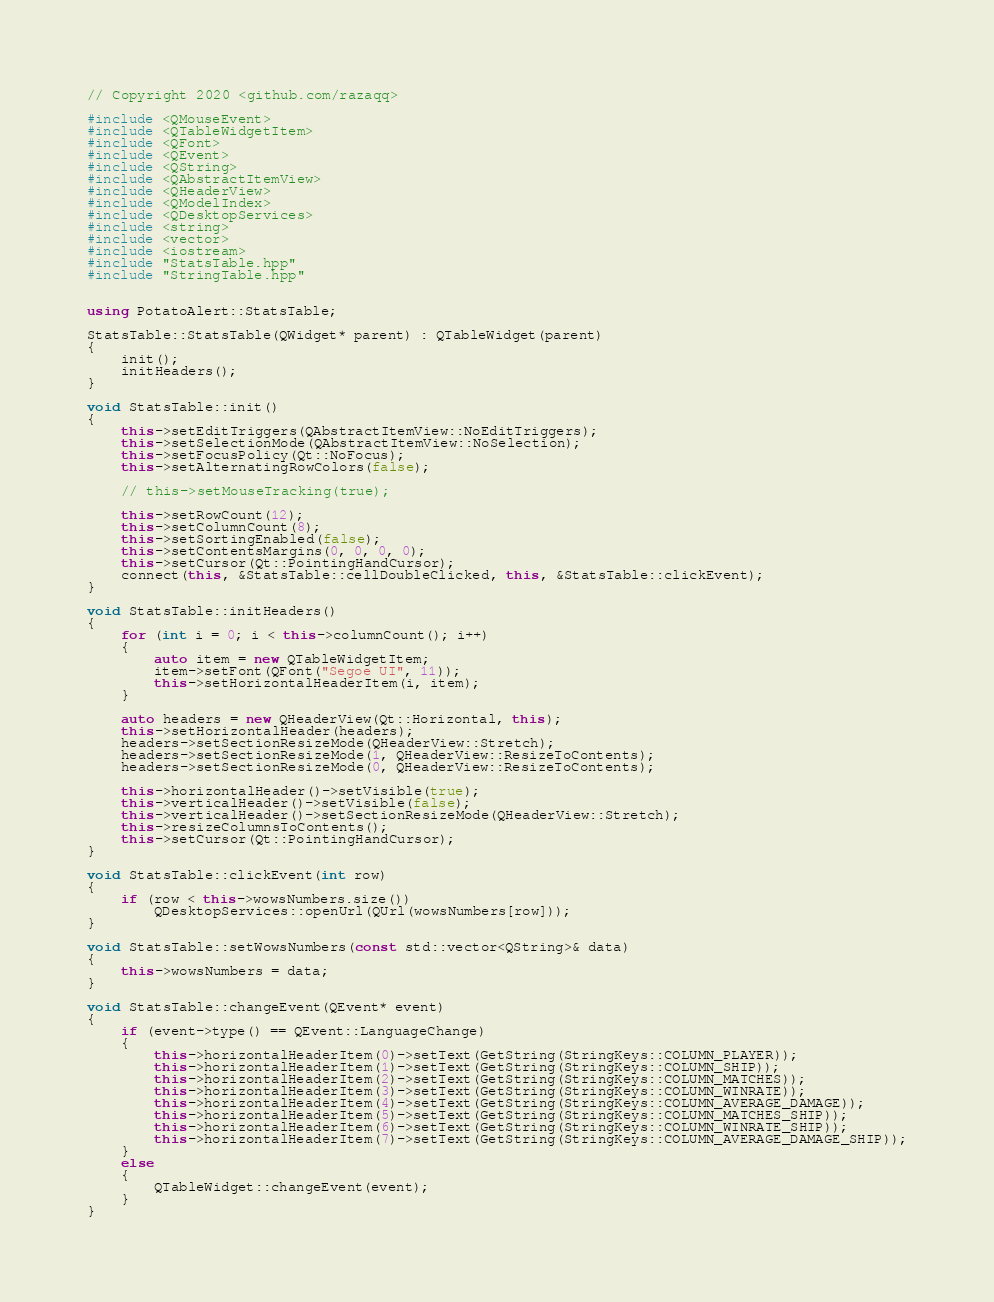<code> <loc_0><loc_0><loc_500><loc_500><_C++_>// Copyright 2020 <github.com/razaqq>

#include <QMouseEvent>
#include <QTableWidgetItem>
#include <QFont>
#include <QEvent>
#include <QString>
#include <QAbstractItemView>
#include <QHeaderView>
#include <QModelIndex>
#include <QDesktopServices>
#include <string>
#include <vector>
#include <iostream>
#include "StatsTable.hpp"
#include "StringTable.hpp"


using PotatoAlert::StatsTable;

StatsTable::StatsTable(QWidget* parent) : QTableWidget(parent)
{
	init();
	initHeaders();
}

void StatsTable::init()
{
	this->setEditTriggers(QAbstractItemView::NoEditTriggers);
	this->setSelectionMode(QAbstractItemView::NoSelection);
	this->setFocusPolicy(Qt::NoFocus);
	this->setAlternatingRowColors(false);

	// this->setMouseTracking(true);

	this->setRowCount(12);
	this->setColumnCount(8);
	this->setSortingEnabled(false);
	this->setContentsMargins(0, 0, 0, 0);
	this->setCursor(Qt::PointingHandCursor);
	connect(this, &StatsTable::cellDoubleClicked, this, &StatsTable::clickEvent);
}

void StatsTable::initHeaders()
{
	for (int i = 0; i < this->columnCount(); i++)
	{
		auto item = new QTableWidgetItem;
		item->setFont(QFont("Segoe UI", 11));
		this->setHorizontalHeaderItem(i, item);
	}

	auto headers = new QHeaderView(Qt::Horizontal, this);
	this->setHorizontalHeader(headers);
	headers->setSectionResizeMode(QHeaderView::Stretch);
	headers->setSectionResizeMode(1, QHeaderView::ResizeToContents);
	headers->setSectionResizeMode(0, QHeaderView::ResizeToContents);

	this->horizontalHeader()->setVisible(true);
	this->verticalHeader()->setVisible(false);
	this->verticalHeader()->setSectionResizeMode(QHeaderView::Stretch);
	this->resizeColumnsToContents();
	this->setCursor(Qt::PointingHandCursor);
}

void StatsTable::clickEvent(int row)
{
	if (row < this->wowsNumbers.size())
		QDesktopServices::openUrl(QUrl(wowsNumbers[row]));
}

void StatsTable::setWowsNumbers(const std::vector<QString>& data)
{
	this->wowsNumbers = data;
}

void StatsTable::changeEvent(QEvent* event)
{
	if (event->type() == QEvent::LanguageChange)
	{
		this->horizontalHeaderItem(0)->setText(GetString(StringKeys::COLUMN_PLAYER));
		this->horizontalHeaderItem(1)->setText(GetString(StringKeys::COLUMN_SHIP));
		this->horizontalHeaderItem(2)->setText(GetString(StringKeys::COLUMN_MATCHES));
		this->horizontalHeaderItem(3)->setText(GetString(StringKeys::COLUMN_WINRATE));
		this->horizontalHeaderItem(4)->setText(GetString(StringKeys::COLUMN_AVERAGE_DAMAGE));
		this->horizontalHeaderItem(5)->setText(GetString(StringKeys::COLUMN_MATCHES_SHIP));
		this->horizontalHeaderItem(6)->setText(GetString(StringKeys::COLUMN_WINRATE_SHIP));
		this->horizontalHeaderItem(7)->setText(GetString(StringKeys::COLUMN_AVERAGE_DAMAGE_SHIP));
	}
	else
	{
		QTableWidget::changeEvent(event);
	}
}
</code> 